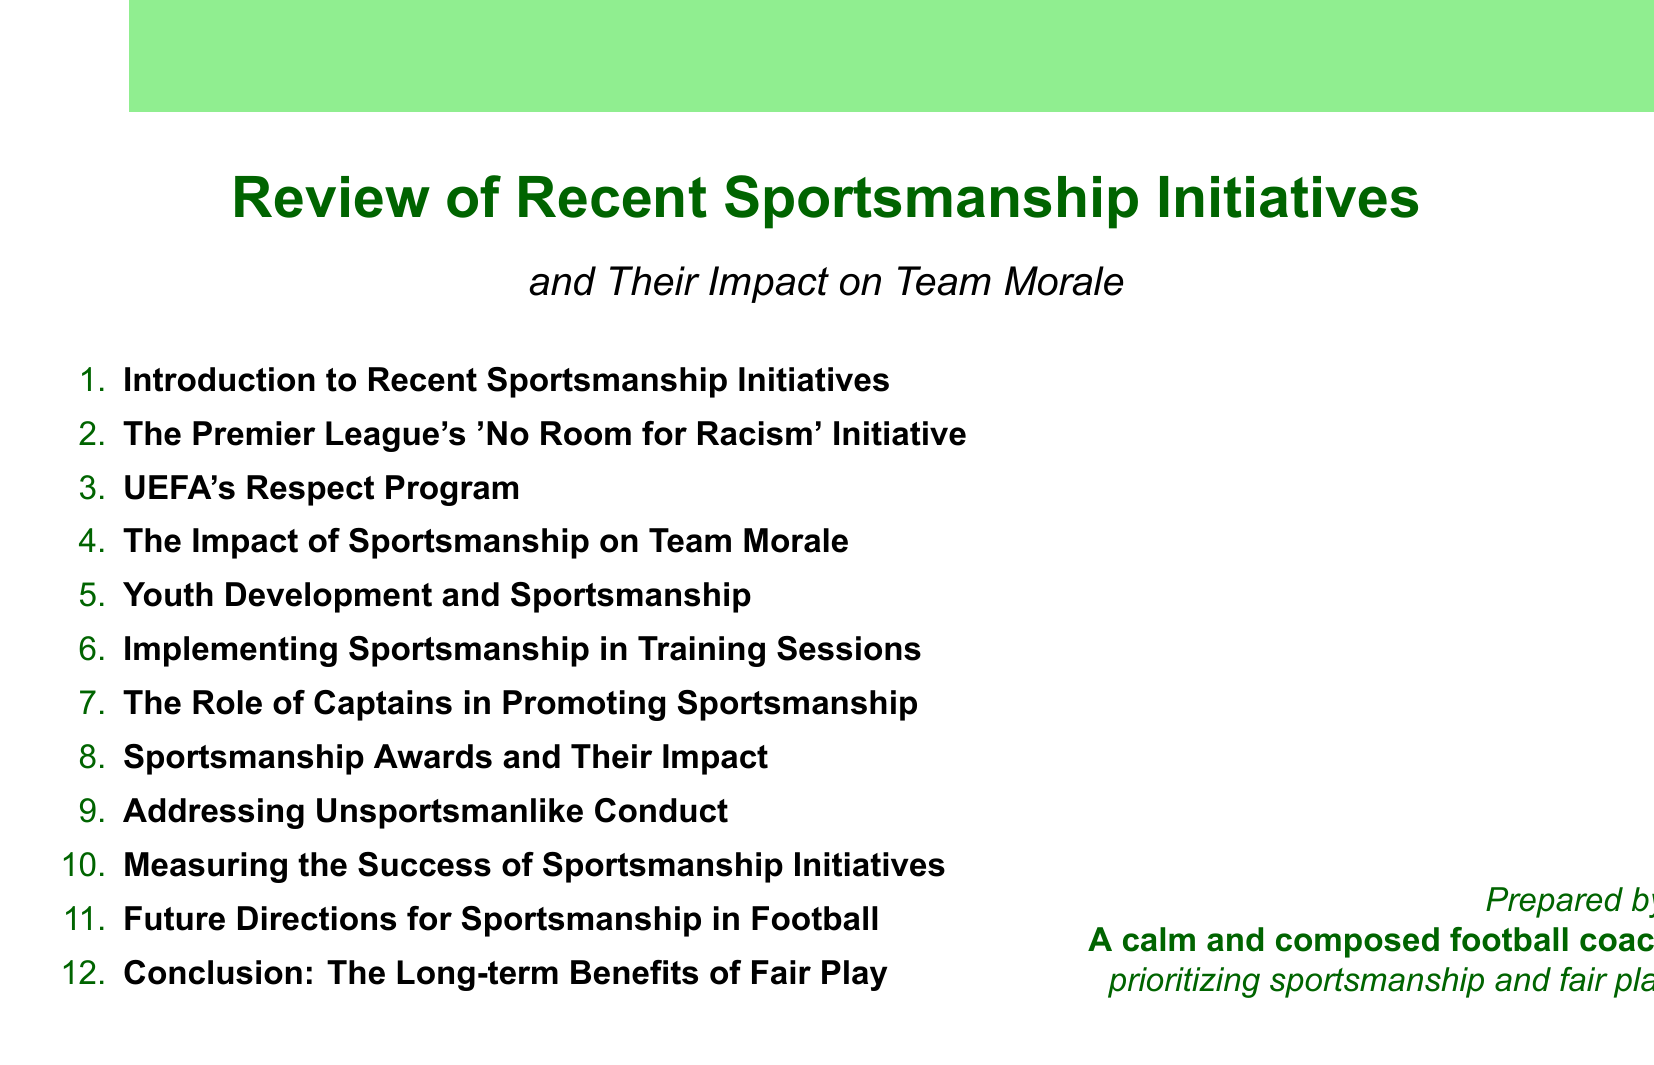What is the title of the first agenda item? The first agenda item is titled "Introduction to Recent Sportsmanship Initiatives."
Answer: Introduction to Recent Sportsmanship Initiatives What initiative does the Premier League focus on? The Premier League focuses on the "No Room for Racism" initiative.
Answer: No Room for Racism Which club is highlighted in the case study on team morale? The case study discusses Liverpool FC's emphasis on fair play.
Answer: Liverpool FC What is the aim of UEFA's Respect Program? UEFA's Respect Program aims to influence player behavior and referee-player interactions.
Answer: Influence player behavior and referee-player interactions Who are mentioned as role models for promoting sportsmanship? The document mentions Jordan Henderson and Vincent Kompany as role models.
Answer: Jordan Henderson and Vincent Kompany What is analyzed in the section on Sportsmanship Awards? The section analyzes the FIFA Fair Play Award's impact on motivating teams.
Answer: FIFA Fair Play Award's impact on motivating teams What does the document suggest for future sportsmanship initiatives? The document discusses potential new initiatives, including technology use.
Answer: Technology use What organization leads the initiative for youth development in sportsmanship? The English FA leads the initiative for youth development in sportsmanship.
Answer: English FA What is the concluding theme of the document? The concluding theme reflects on sustained commitment to sportsmanship.
Answer: Sustained commitment to sportsmanship 